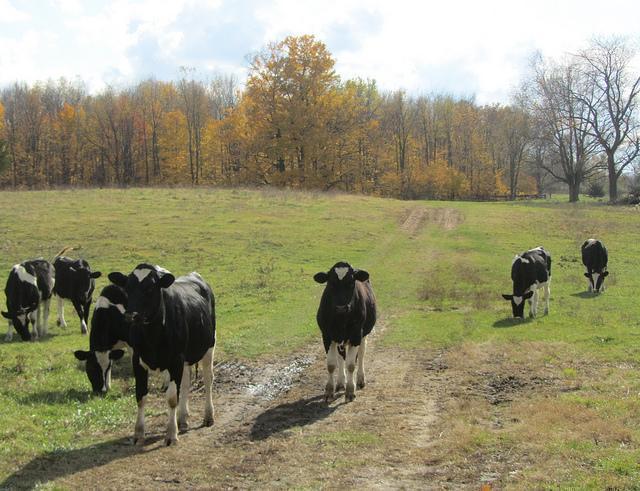What likely made the tracks on the ground?
Make your selection and explain in format: 'Answer: answer
Rationale: rationale.'
Options: Plane, skis, cows, truck. Answer: truck.
Rationale: There are two rows of tires and cows need extra feed sometimes. 